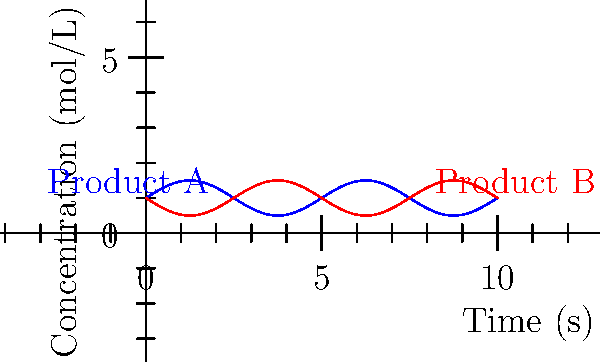The graph shows the concentration of two products (A and B) in a periodic chemical reaction over time. The concentrations can be modeled by sinusoidal functions. If the period of the reaction is 5 seconds, what is the frequency of the oscillation in Hz? To find the frequency of the oscillation, we need to follow these steps:

1. Recall the relationship between period (T) and frequency (f):
   $$f = \frac{1}{T}$$

2. We are given that the period of the reaction is 5 seconds:
   $$T = 5\text{ s}$$

3. Substitute this value into the frequency formula:
   $$f = \frac{1}{5\text{ s}}$$

4. Simplify:
   $$f = 0.2\text{ s}^{-1}$$

5. Convert the unit to Hz (which is equivalent to s⁻¹):
   $$f = 0.2\text{ Hz}$$

Therefore, the frequency of the oscillation is 0.2 Hz.
Answer: 0.2 Hz 